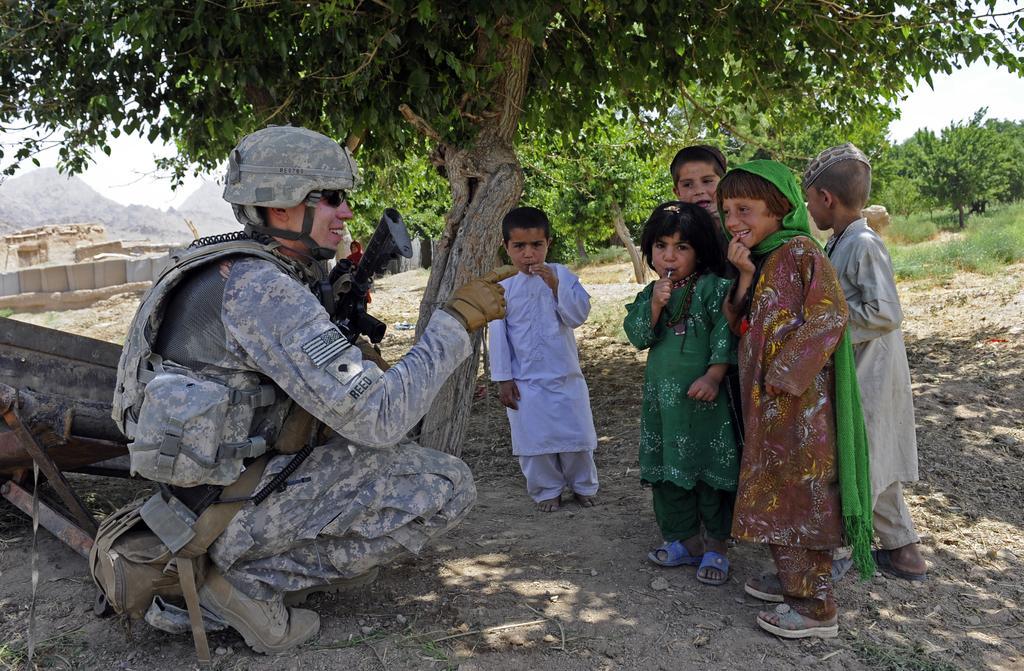Can you describe this image briefly? In this image we can see a person wearing military uniform and carrying bags is wearing a helmet and goggles and gloves on his hand. On the right side of the image we can see a group of children standing on the ground. In the background, we can see a group of trees, building, mountains and a sky. 